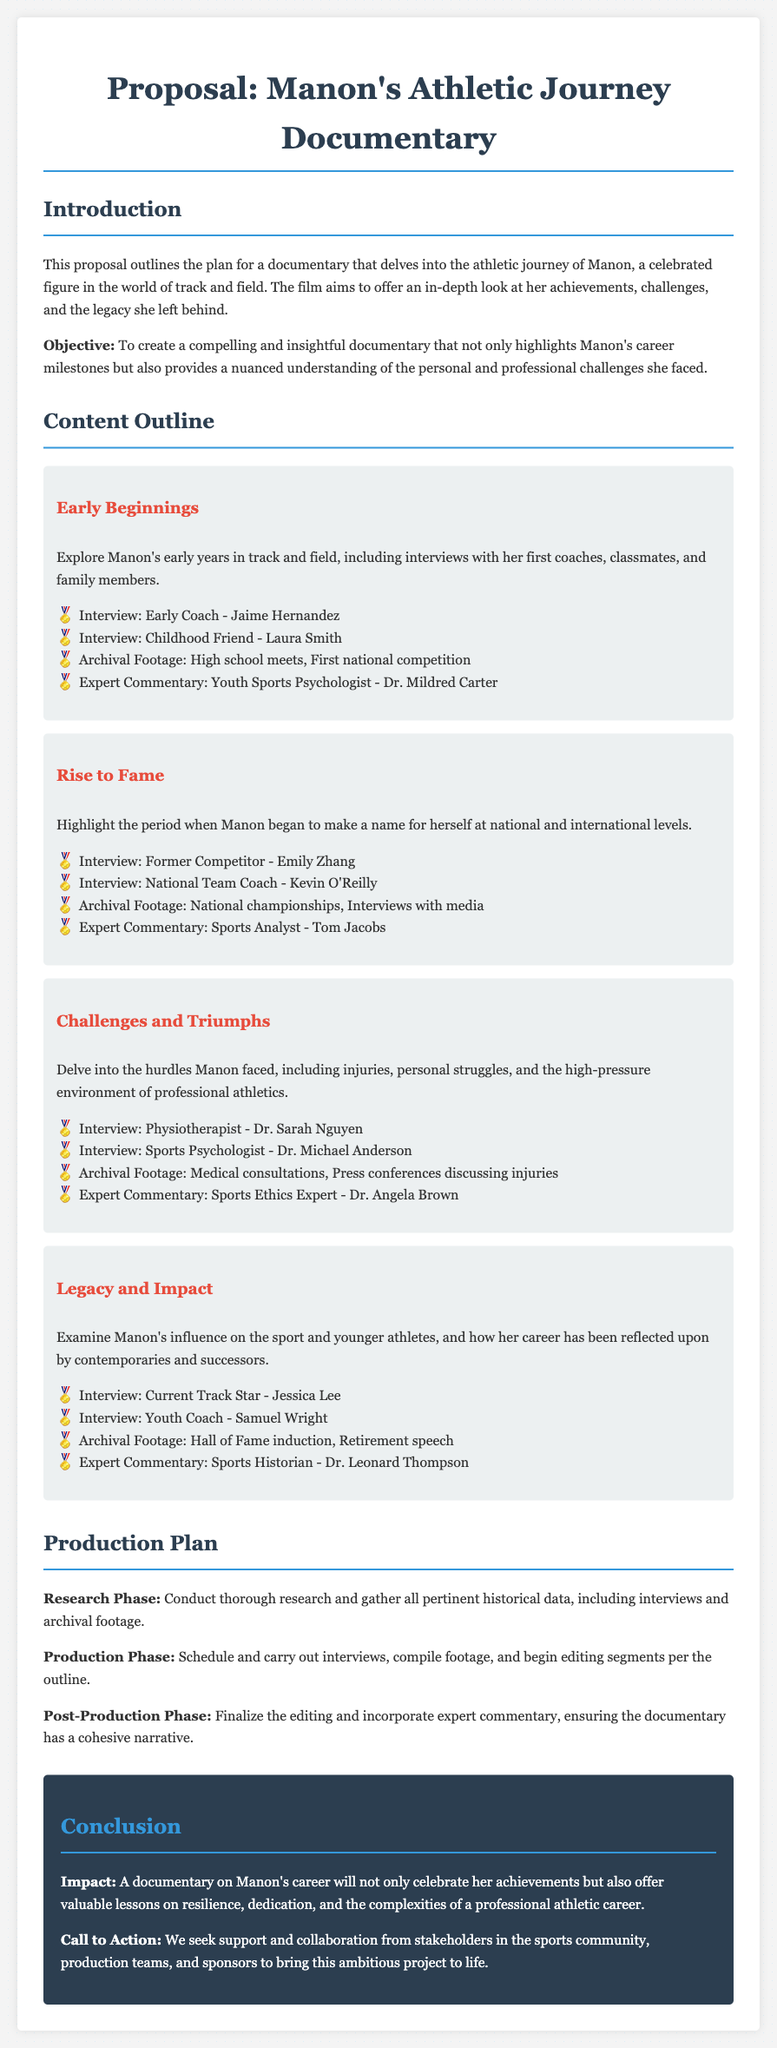What is the title of the documentary? The title of the documentary is mentioned in the header of the proposal.
Answer: Manon's Athletic Journey Documentary Who is the featured athlete in the documentary? The proposal clearly identifies the central figure whose career is being chronicled.
Answer: Manon What is the focus of the documentary? The objective section provides insight into what the documentary aims to achieve.
Answer: Highlights Manon's career milestones and challenges What type of expert commentary is included in the "Early Beginnings" section? The document lists various experts providing commentary throughout different sections.
Answer: Youth Sports Psychologist How many segments are there in the Content Outline? By counting the segments listed under the Content Outline, the total can be determined.
Answer: Four Which coach is interviewed in the "Rise to Fame" segment? The proposal lists specific interviews associated with each segment, allowing identification.
Answer: Kevin O'Reilly What is one of the topics covered in the "Challenges and Triumphs" segment? By reviewing the challenges mentioned in the segment, the information can be summarized.
Answer: Injuries What is the production phase listed in the Production Plan? The Production Plan describes different phases involved in creating the documentary.
Answer: Schedule and carry out interviews What type of call to action is included in the conclusion? The final section outlines what the proposal seeks from the audience.
Answer: Support and collaboration from stakeholders 